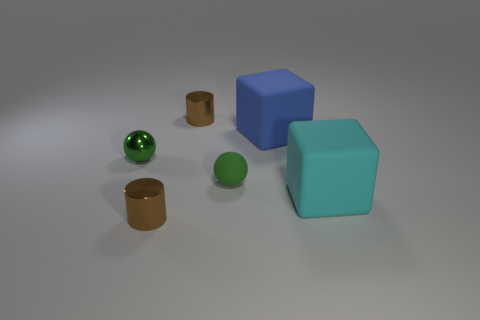What number of purple metal objects have the same size as the blue matte object?
Keep it short and to the point. 0. What is the color of the small rubber ball?
Keep it short and to the point. Green. There is a small shiny sphere; is it the same color as the rubber object that is on the left side of the big blue rubber block?
Make the answer very short. Yes. There is a ball that is made of the same material as the cyan block; what is its size?
Your answer should be very brief. Small. Is there another small sphere that has the same color as the small metallic ball?
Give a very brief answer. Yes. How many things are tiny brown metallic things in front of the cyan object or small brown matte blocks?
Provide a short and direct response. 1. Do the large cyan object and the large object behind the small rubber object have the same material?
Make the answer very short. Yes. What is the size of the thing that is the same color as the small rubber sphere?
Offer a very short reply. Small. Are there any blue blocks that have the same material as the large cyan cube?
Keep it short and to the point. Yes. How many objects are either shiny cylinders that are behind the cyan rubber object or objects that are behind the small green matte ball?
Your answer should be compact. 3. 